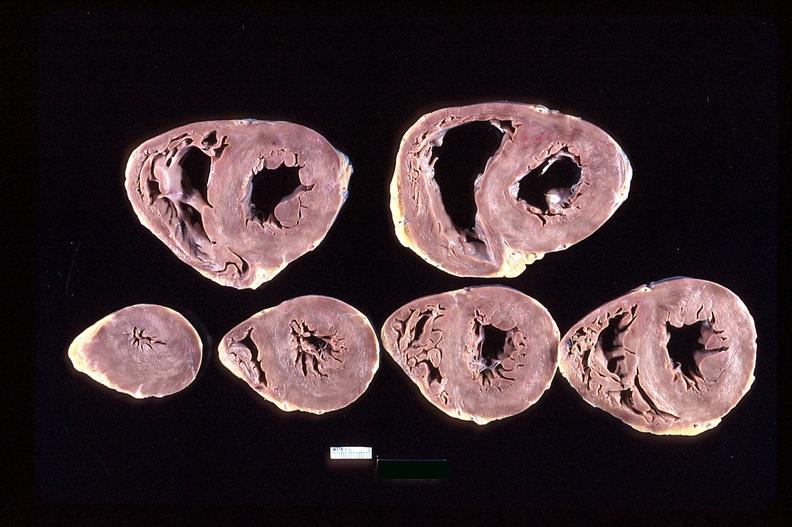does omentum show heart slices, acute posterior myocardial infarction in patient with hypertension?
Answer the question using a single word or phrase. No 